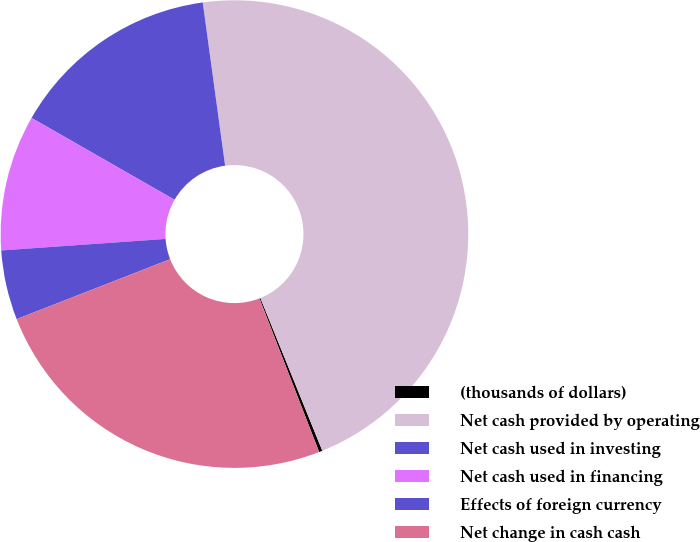Convert chart. <chart><loc_0><loc_0><loc_500><loc_500><pie_chart><fcel>(thousands of dollars)<fcel>Net cash provided by operating<fcel>Net cash used in investing<fcel>Net cash used in financing<fcel>Effects of foreign currency<fcel>Net change in cash cash<nl><fcel>0.23%<fcel>46.04%<fcel>14.56%<fcel>9.39%<fcel>4.81%<fcel>24.98%<nl></chart> 